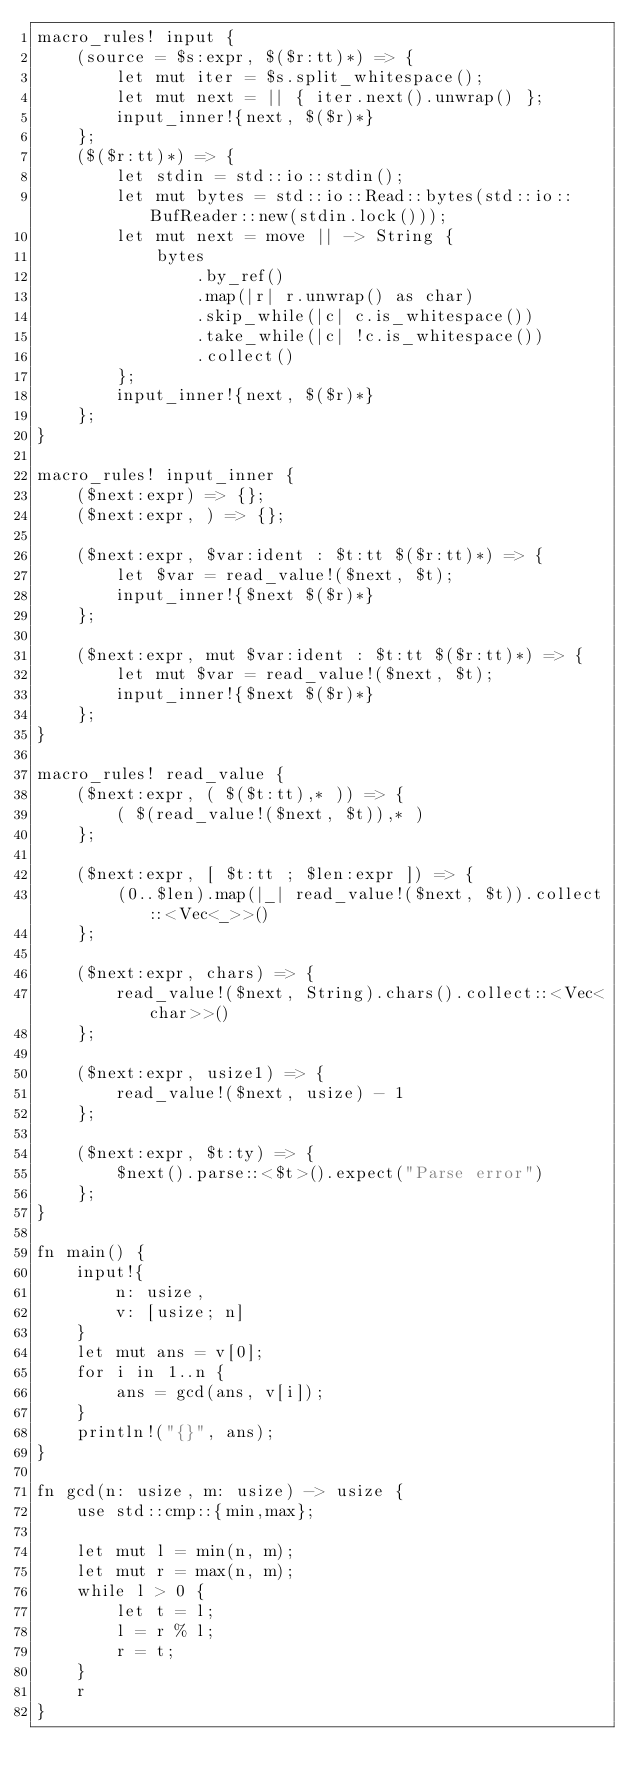Convert code to text. <code><loc_0><loc_0><loc_500><loc_500><_Rust_>macro_rules! input {
    (source = $s:expr, $($r:tt)*) => {
        let mut iter = $s.split_whitespace();
        let mut next = || { iter.next().unwrap() };
        input_inner!{next, $($r)*}
    };
    ($($r:tt)*) => {
        let stdin = std::io::stdin();
        let mut bytes = std::io::Read::bytes(std::io::BufReader::new(stdin.lock()));
        let mut next = move || -> String {
            bytes
                .by_ref()
                .map(|r| r.unwrap() as char)
                .skip_while(|c| c.is_whitespace())
                .take_while(|c| !c.is_whitespace())
                .collect()
        };
        input_inner!{next, $($r)*}
    };
}

macro_rules! input_inner {
    ($next:expr) => {};
    ($next:expr, ) => {};

    ($next:expr, $var:ident : $t:tt $($r:tt)*) => {
        let $var = read_value!($next, $t);
        input_inner!{$next $($r)*}
    };

    ($next:expr, mut $var:ident : $t:tt $($r:tt)*) => {
        let mut $var = read_value!($next, $t);
        input_inner!{$next $($r)*}
    };
}

macro_rules! read_value {
    ($next:expr, ( $($t:tt),* )) => {
        ( $(read_value!($next, $t)),* )
    };

    ($next:expr, [ $t:tt ; $len:expr ]) => {
        (0..$len).map(|_| read_value!($next, $t)).collect::<Vec<_>>()
    };

    ($next:expr, chars) => {
        read_value!($next, String).chars().collect::<Vec<char>>()
    };

    ($next:expr, usize1) => {
        read_value!($next, usize) - 1
    };

    ($next:expr, $t:ty) => {
        $next().parse::<$t>().expect("Parse error")
    };
}

fn main() {
    input!{
        n: usize,
        v: [usize; n]
    }
    let mut ans = v[0];
    for i in 1..n {
        ans = gcd(ans, v[i]);
    }
    println!("{}", ans);
}

fn gcd(n: usize, m: usize) -> usize {
    use std::cmp::{min,max};

    let mut l = min(n, m);
    let mut r = max(n, m);
    while l > 0 {
        let t = l;
        l = r % l;
        r = t;
    }
    r
}
</code> 